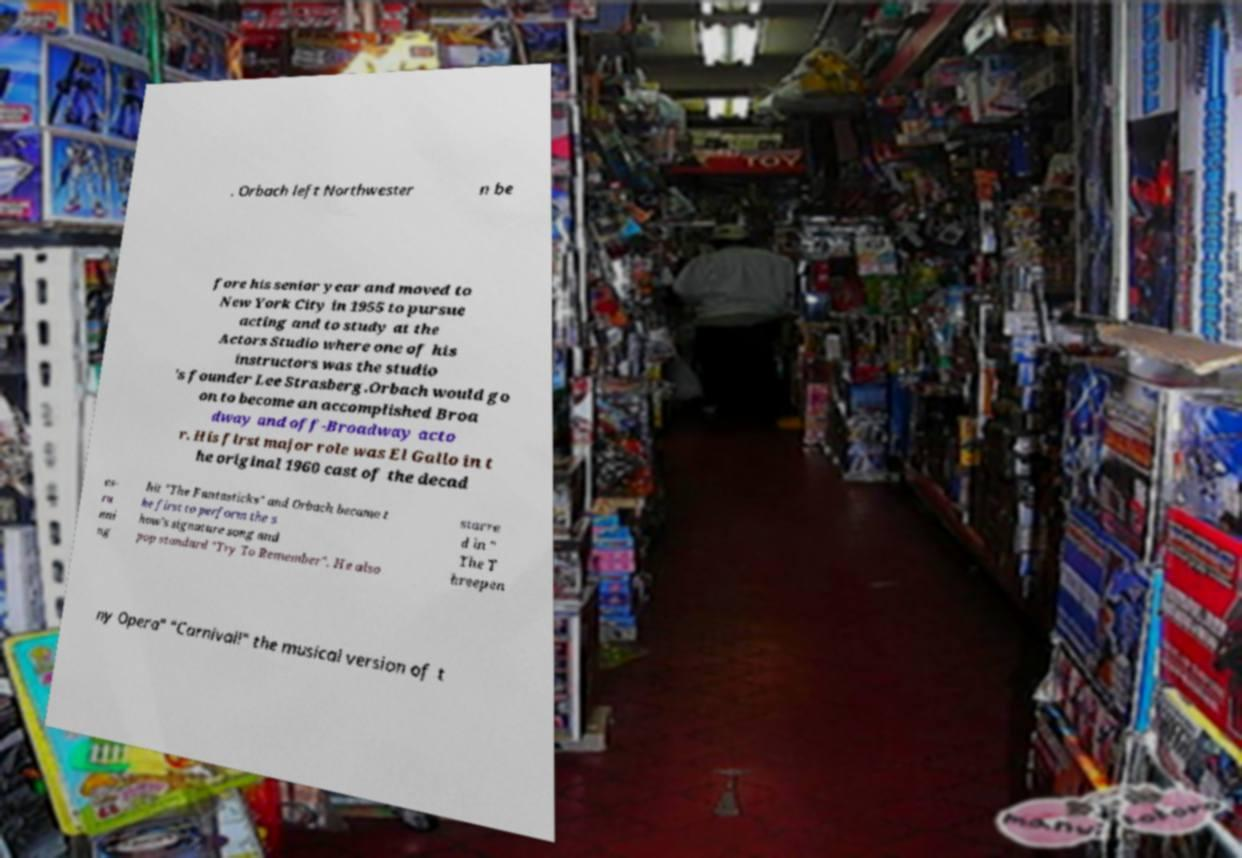For documentation purposes, I need the text within this image transcribed. Could you provide that? . Orbach left Northwester n be fore his senior year and moved to New York City in 1955 to pursue acting and to study at the Actors Studio where one of his instructors was the studio 's founder Lee Strasberg.Orbach would go on to become an accomplished Broa dway and off-Broadway acto r. His first major role was El Gallo in t he original 1960 cast of the decad es- ru nni ng hit "The Fantasticks" and Orbach became t he first to perform the s how's signature song and pop standard "Try To Remember". He also starre d in " The T hreepen ny Opera" "Carnival!" the musical version of t 